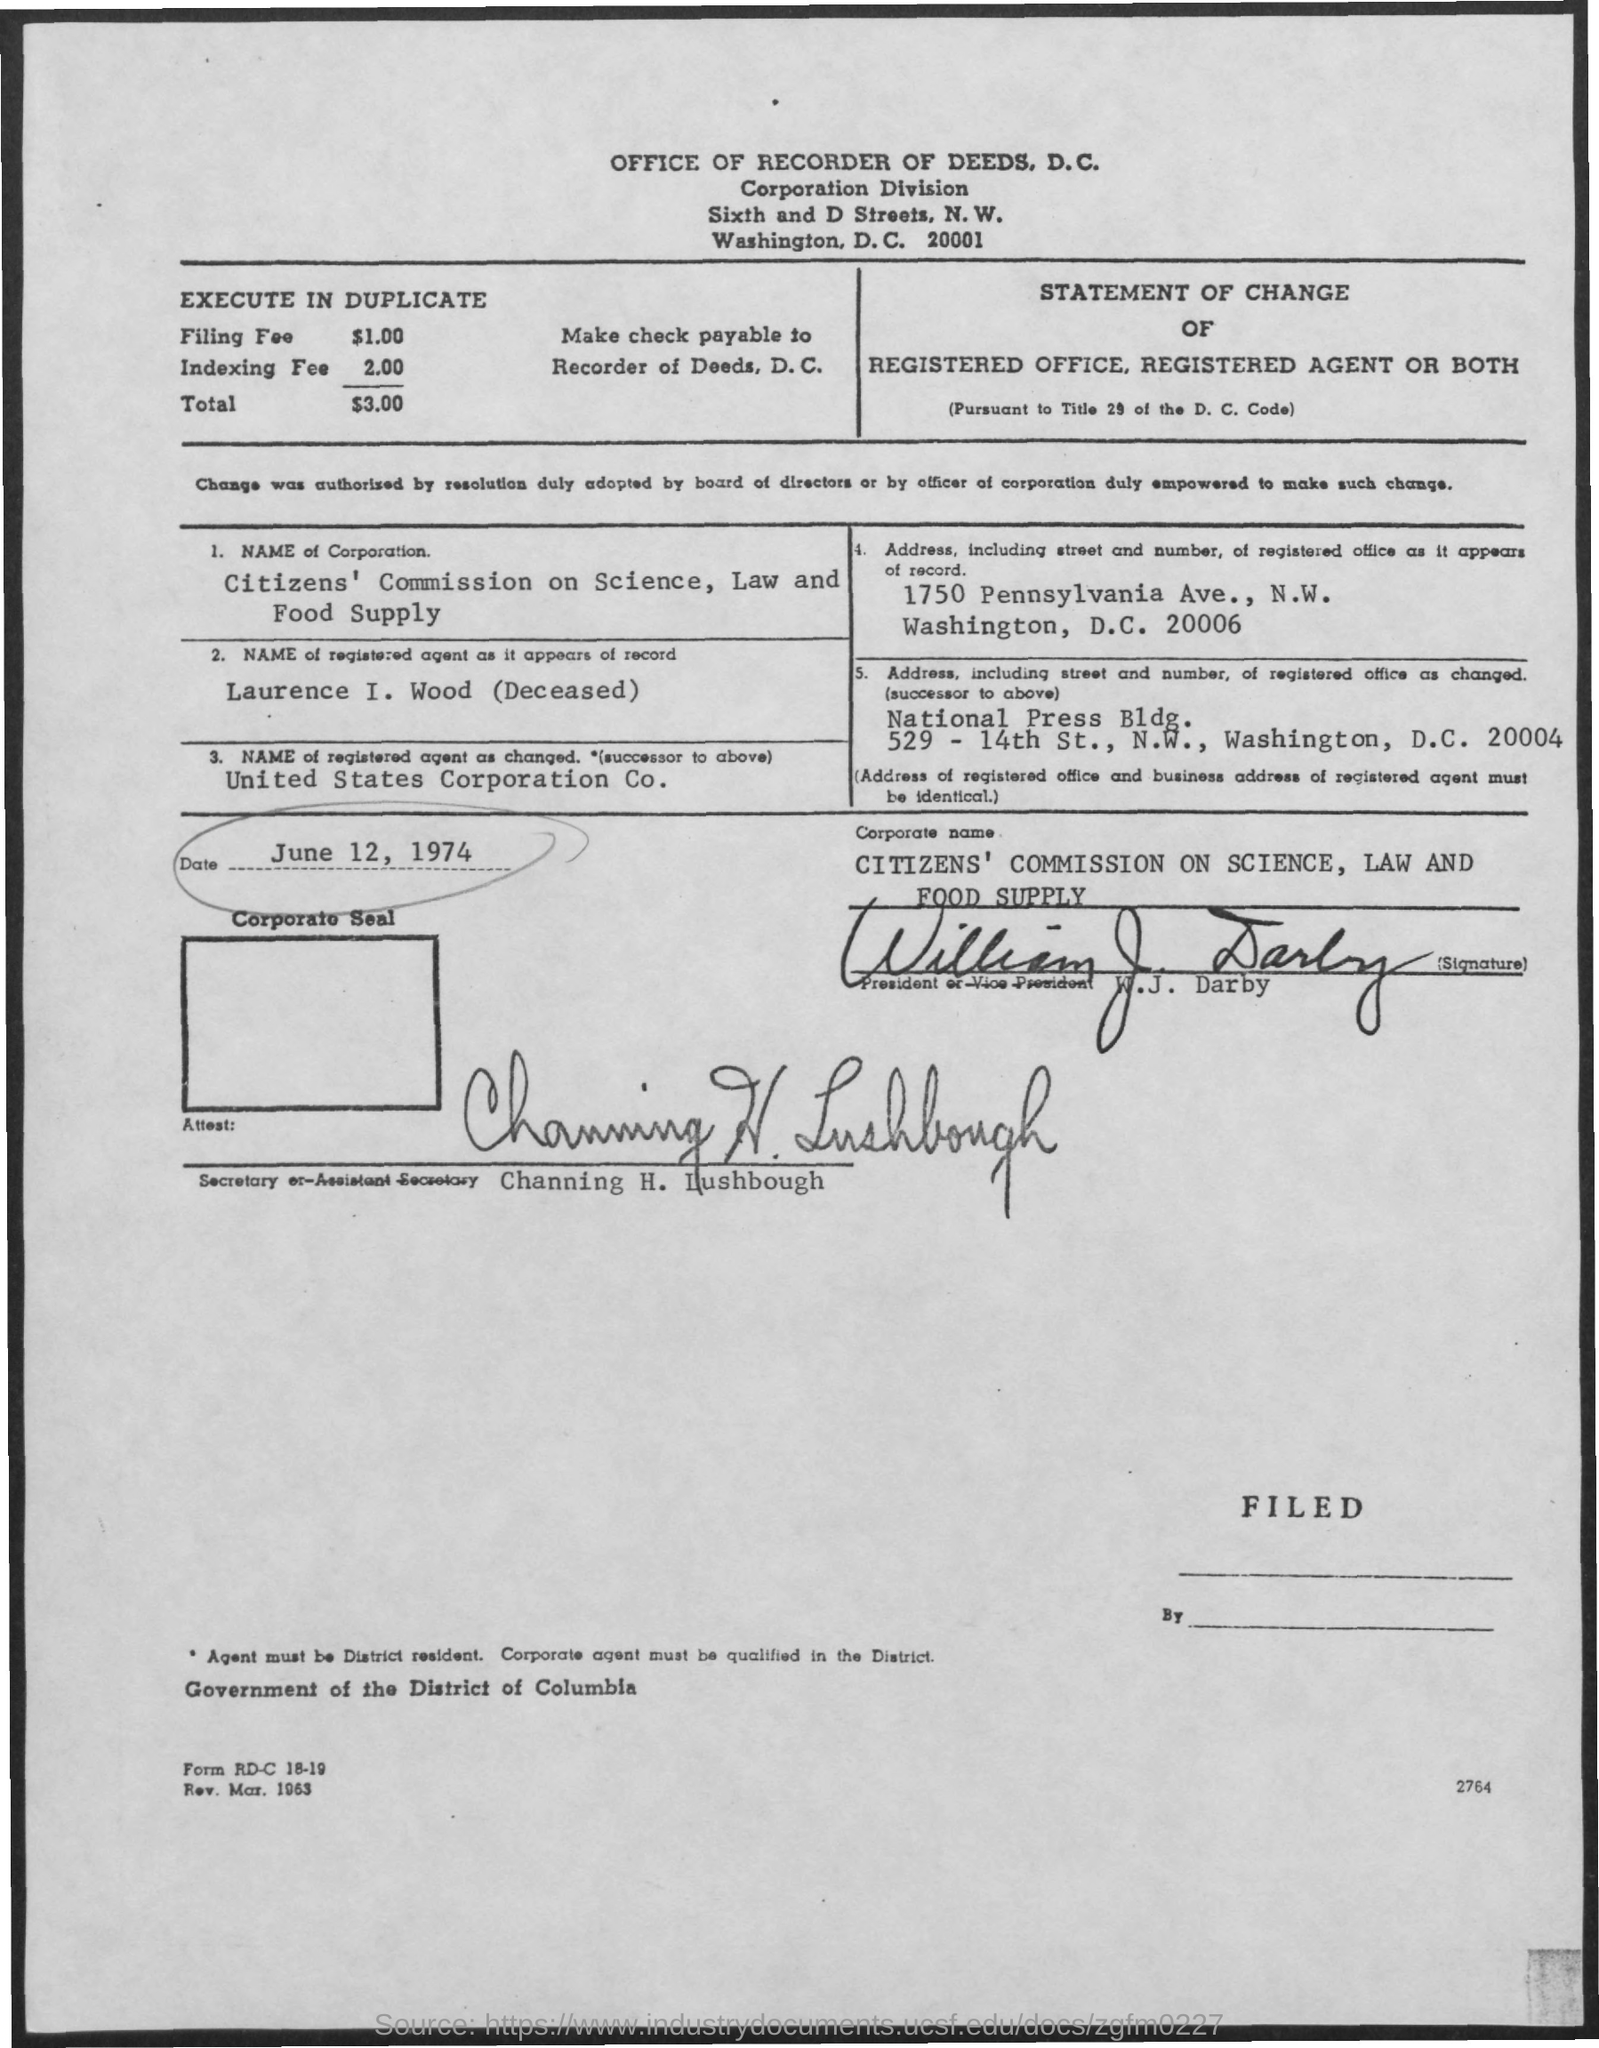Mention a couple of crucial points in this snapshot. The registered agent's name has been changed to United States Corporation Company. The date mentioned is June 12, 1974. Channing H. Lushbough is the Secretary or Assistant Secretary. The registered agent's name as it appears on record is Laurence I. Wood (Deceased). The name of the corporation is the Citizens' Commission on Science, Law and Food Supply. 